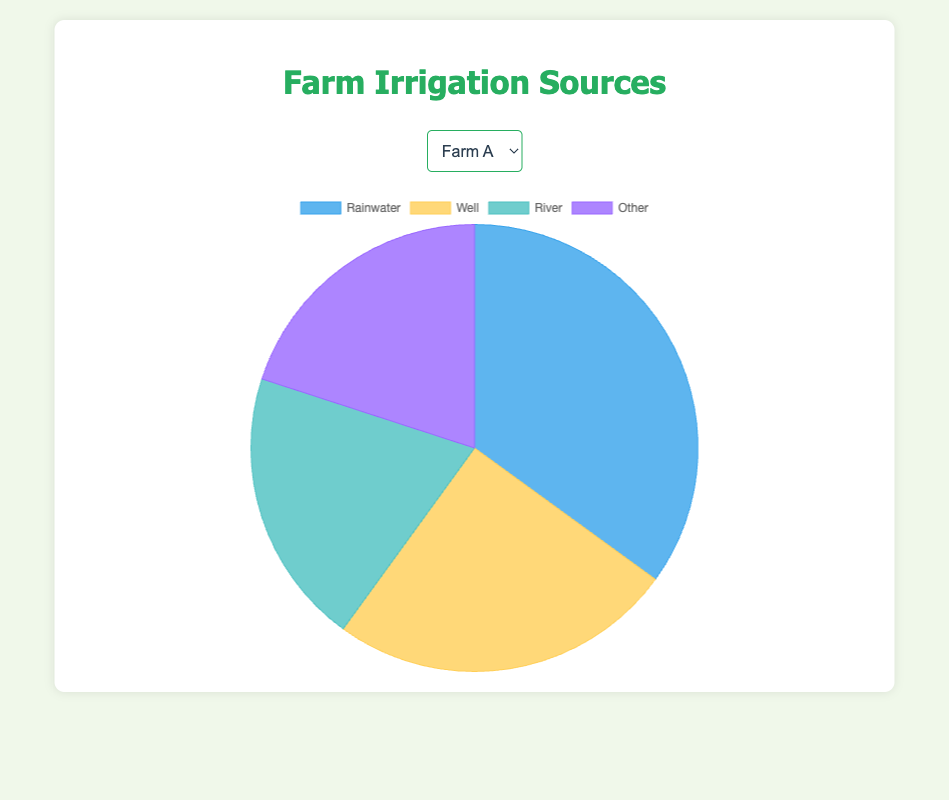What is the dominant irrigation source for Farm A? Looking at the pie chart for Farm A, the section representing "Rainwater" is the largest, indicating it is the dominant source.
Answer: Rainwater Which farm uses the most well water? By comparing the "Well" sections across all farms, Farm C has the largest piece, indicating it uses the most well water.
Answer: Farm C What is the total percentage of river and other sources for Farm B? Adding the percentages for "River" (15%) and "Other" (15%) for Farm B, the total is 15% + 15% = 30%.
Answer: 30% Which farm relies least on rainwater? By comparing the "Rainwater" sections, Farm C's section is the smallest at 20%, indicating it relies the least on rainwater.
Answer: Farm C How much more does Farm D use river water compared to well water? Farm D uses 25% river water and 15% well water. The difference is 25% - 15% = 10%.
Answer: 10% What is the average percentage of well water used across all farms? Summing up the well water percentages for all farms (25% + 20% + 40% + 15%) gives 100%. Dividing by the number of farms (4) results in an average of 100% / 4 = 25%.
Answer: 25% In terms of visual size, which section on the pie chart for Farm C appears largest and smallest? For Farm C, the largest section is "Well" and the smallest section is "Other," based on their visual size.
Answer: Well (largest), Other (smallest) What is the combined percentage of rainwater and river sources for Farm A? Adding the percentages of rainwater (35%) and river (20%) for Farm A gives 35% + 20% = 55%.
Answer: 55% Which farm has the second highest usage of rainwater? Comparing the rainwater percentages, Farm D (45%) has the second highest usage, after Farm B (50%).
Answer: Farm D If the percentage of well water used in Farm D increased by 10%, what would be its new percentage? Starting with 15%, adding 10% more results in 15% + 10% = 25%.
Answer: 25% 